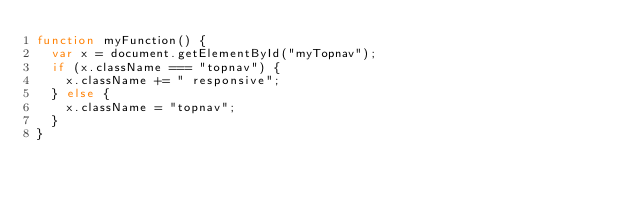<code> <loc_0><loc_0><loc_500><loc_500><_JavaScript_>function myFunction() {
  var x = document.getElementById("myTopnav");
  if (x.className === "topnav") {
    x.className += " responsive";
  } else {
    x.className = "topnav";
  }
}

</code> 